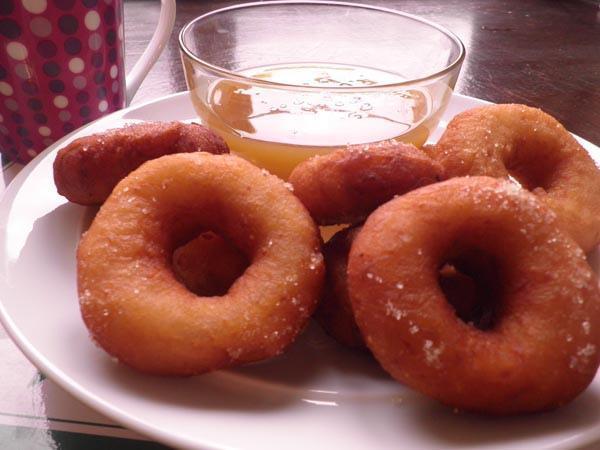How many plates are there?
Give a very brief answer. 1. How many cups do you see?
Give a very brief answer. 1. How many donuts are in the picture?
Give a very brief answer. 6. 